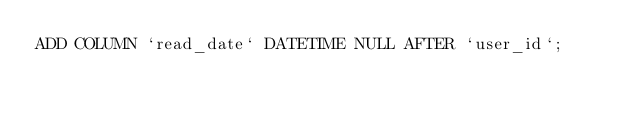<code> <loc_0><loc_0><loc_500><loc_500><_SQL_>ADD COLUMN `read_date` DATETIME NULL AFTER `user_id`;

</code> 